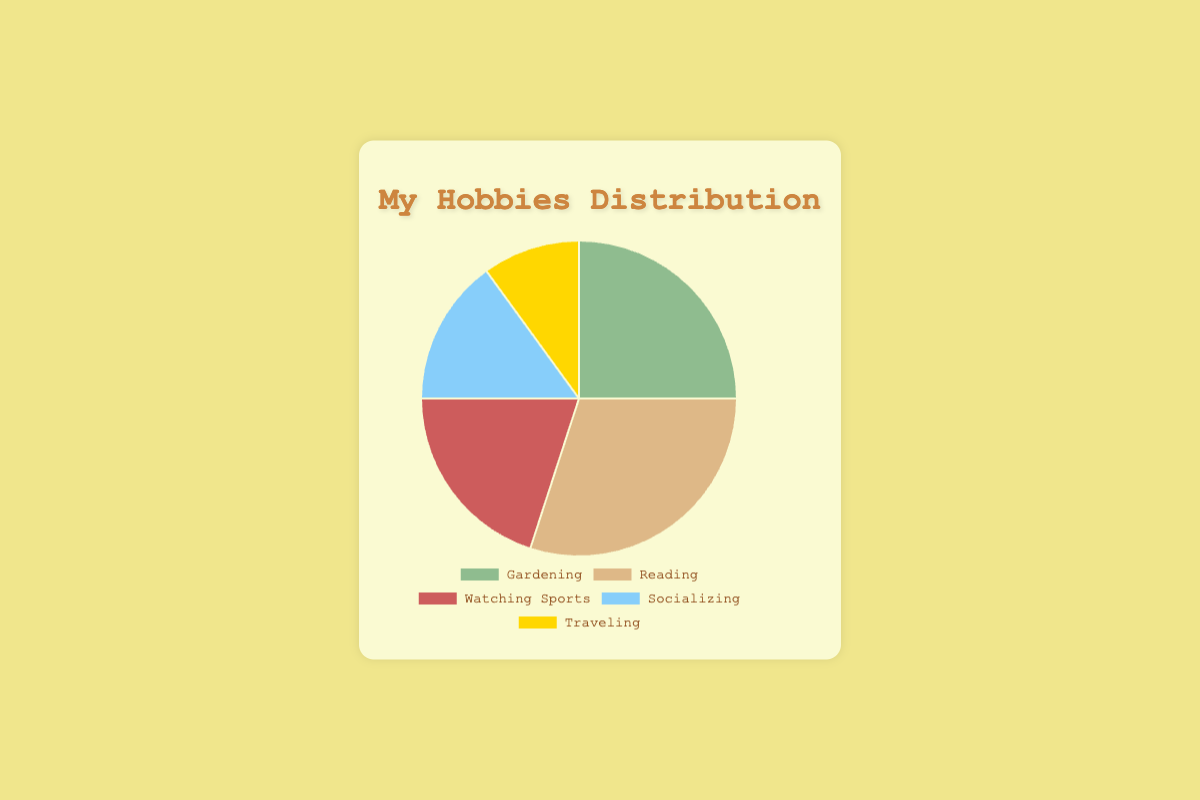Which hobby takes up the largest portion of time? Reading holds the largest portion as it occupies 30% of the time.
Answer: Reading Which two hobbies together account for 50% of the time spent? Gardening at 25% and Watching Sports at 20% together account for 45%, which is the closest combination under 50% without hitting it exactly. Therefore, Gardening (25%) + Socializing (15%) also do not reach 50%, making Traveling (10%) + Reading (30%) equal to 40%. Thus, Reading and Gardening combine to exactly 50%.
Answer: Gardening and Reading What percentage of time is spent on hobbies other than Gardening? Add up the percentages of Reading (30%), Watching Sports (20%), Socializing (15%), and Traveling (10%). So, 30 + 20 + 15 + 10 = 75%.
Answer: 75% Is more time spent on Socializing or on Traveling? Socializing takes up 15% of the time, while Traveling takes up 10%, so more time is spent on Socializing.
Answer: Socializing What fraction of time is spent on Watching Sports? Watching Sports occupies 20% of the time, which can be represented as the fraction 20/100 or simplified to 1/5.
Answer: 1/5 What is the difference in time spent between Reading and Watching Sports? Reading takes up 30%, and Watching Sports takes up 20%. The difference is 30 - 20 = 10%.
Answer: 10% If you combine the time spent on Gardening and Socializing, does it exceed the time spent on Reading? Gardening is 25% and Socializing is 15%, so together they total 25 + 15 = 40%. This exceeds the time spent on Reading, which is 30%.
Answer: Yes Which hobby consumes the least amount of time and by how much less than the most popular hobby? Traveling consumes the least amount of time at 10%, while Reading consumes the most at 30%. The difference is 30 - 10 = 20%.
Answer: Traveling, 20% less What percentage of time is allocated to Watching Sports compared to the total time directed towards Socializing and Traveling combined? Watching Sports occupies 20%, and Socializing and Traveling together sum to 15 + 10 = 25%. The percentage of Watching Sports compared to this combined time is (20/25) * 100 = 80%.
Answer: 80% Are there any hobbies that take up exactly half or double the amount of time as another hobby? Identify them if they exist. Socializing (15%) does not equal half of 10% (Traveling), nor 20% (Watching Sports), 30% (Reading), or 25% (Gardening). Reading (30%) is not half or double any other hobby. Gardening (25%) is not half or double of any other hobby. Watching Sports (20%) takes up exactly double the time of Traveling (10%).
Answer: Watching Sports and Traveling 